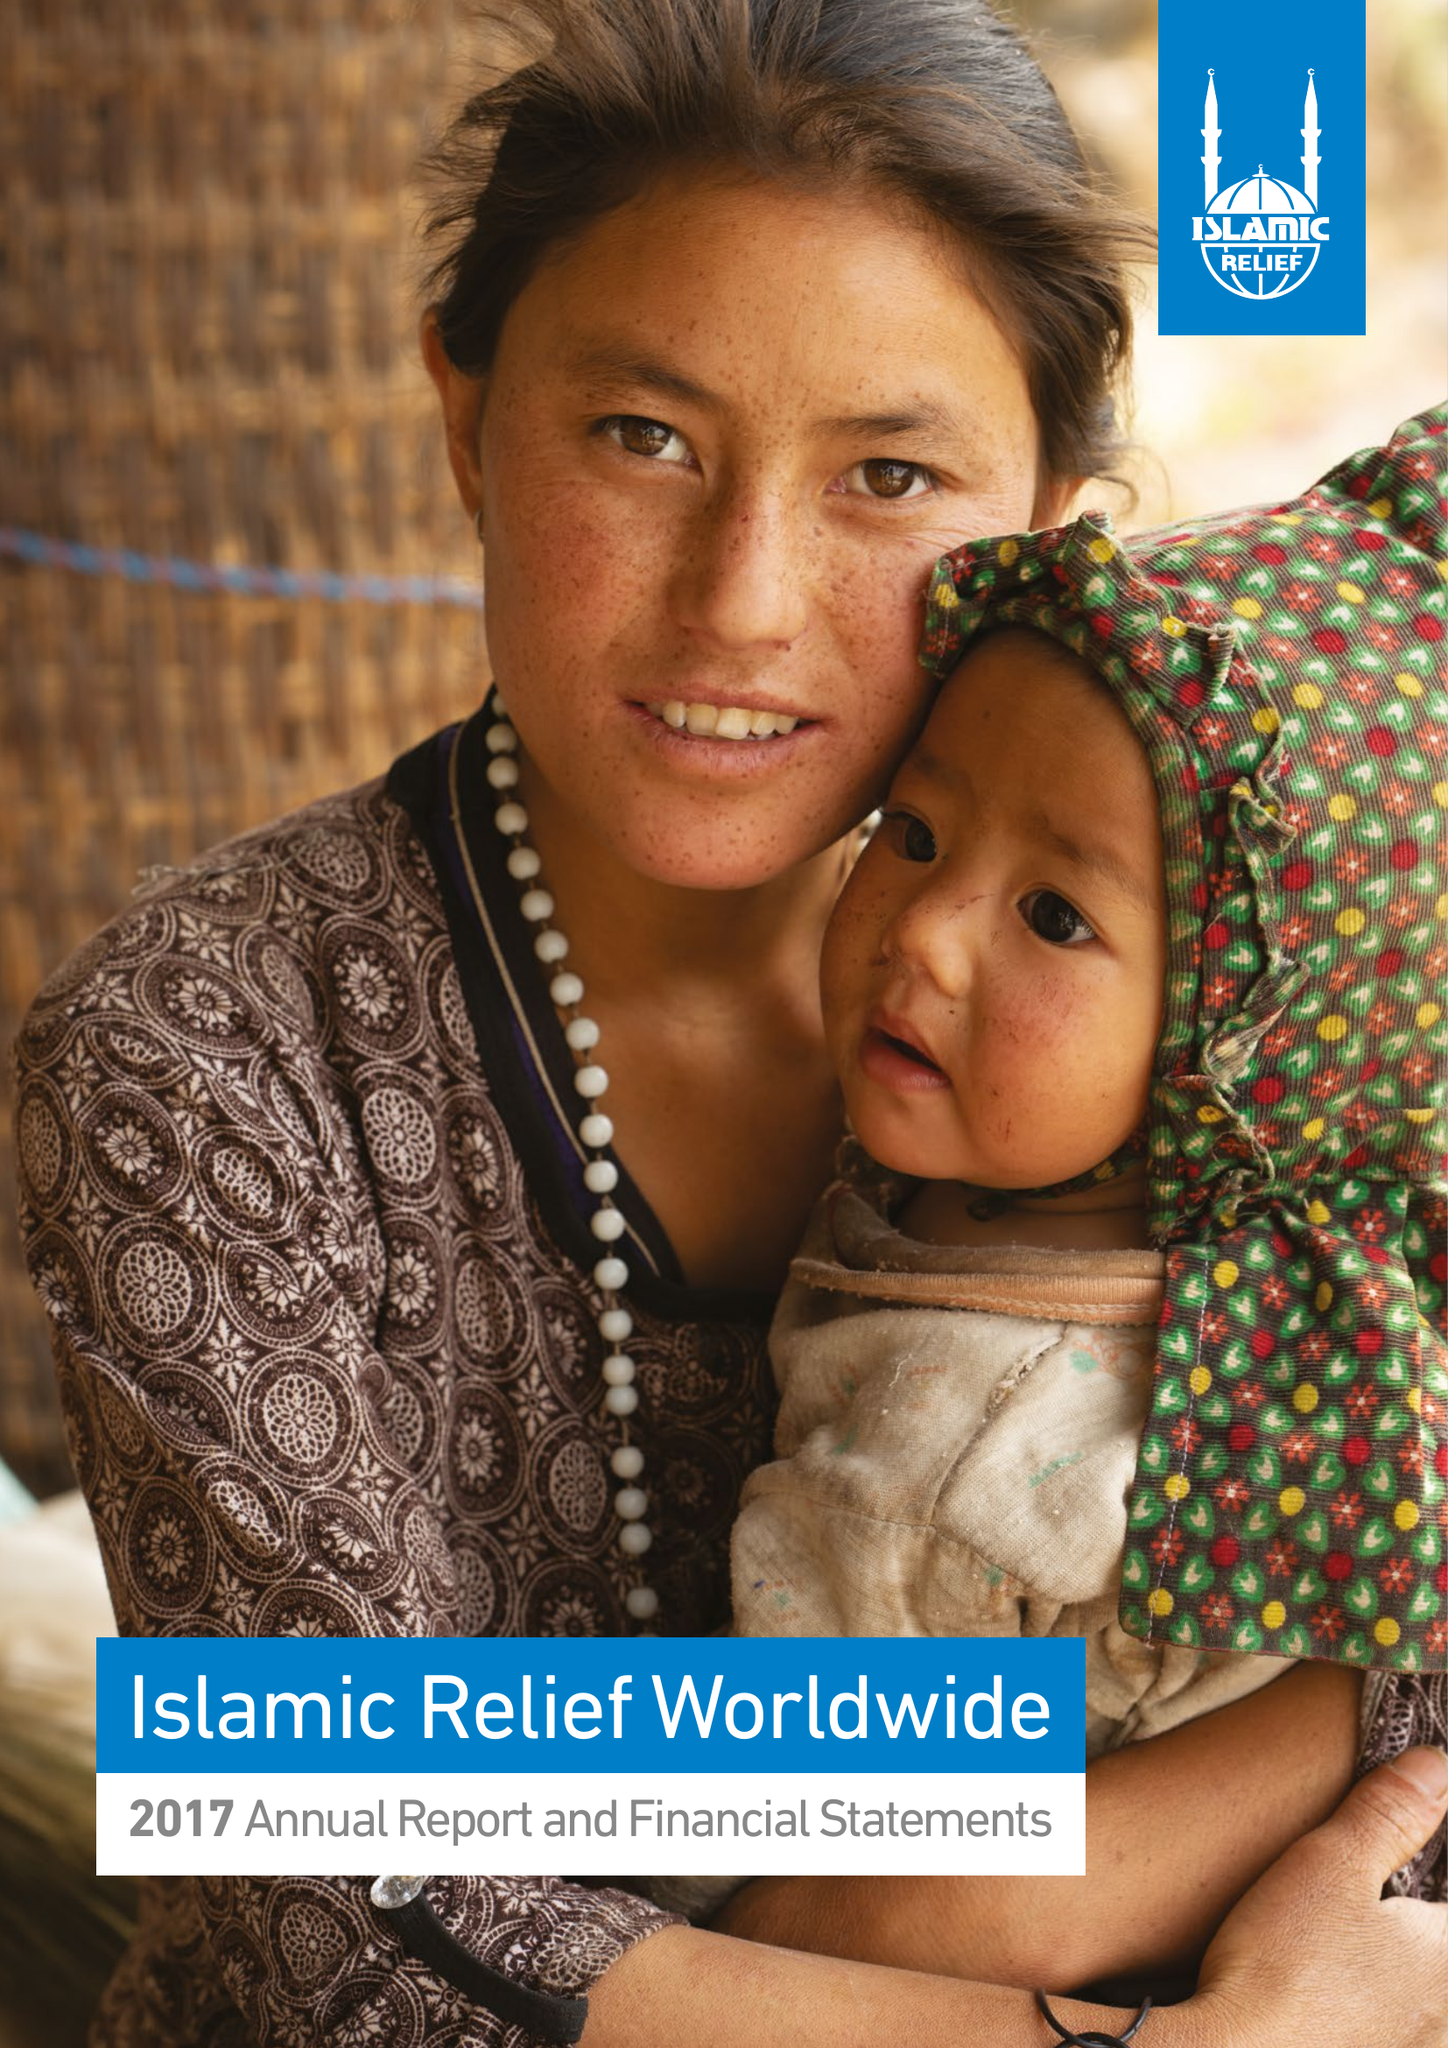What is the value for the address__street_line?
Answer the question using a single word or phrase. 19 REA STREET SOUTH 